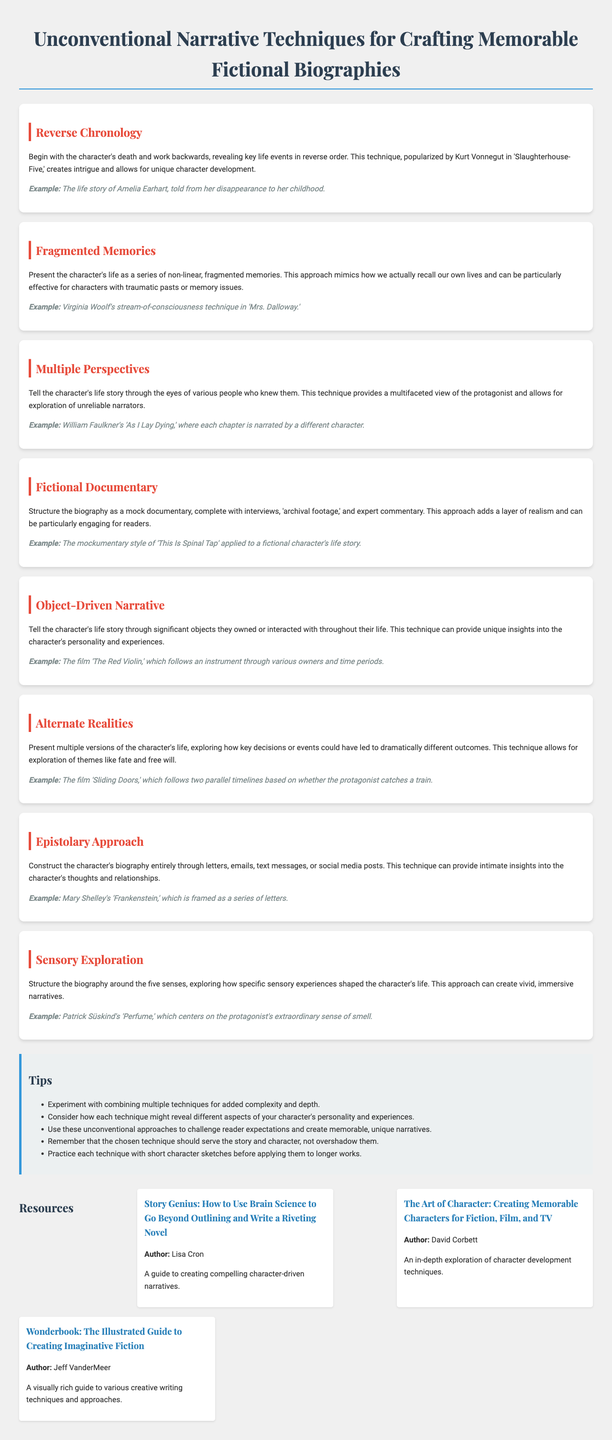What is the title of the brochure? The title of the brochure is provided at the top of the document.
Answer: Unconventional Narrative Techniques for Crafting Memorable Fictional Biographies How many narrative techniques are presented in the brochure? The brochure lists the narrative techniques in separate sections, which can be counted.
Answer: Eight Which technique uses non-linear memories? The technique's name is listed along with its description in the sections.
Answer: Fragmented Memories What example is given for Reverse Chronology? Each technique includes an example; the listed example specifies a particular character's life story.
Answer: The life story of Amelia Earhart, told from her disappearance to her childhood What is one tip provided in the brochure? The tips section contains several suggestions, and this can be retrieved directly from that list.
Answer: Experiment with combining multiple techniques for added complexity and depth Who is the author of "The Art of Character"? The resources section contains titles along with their authors, making this information readily available.
Answer: David Corbett Is "The Red Violin" an example of Object-Driven Narrative? The examples for narrative techniques are specified in the document, and each section provides an example.
Answer: Yes What is the description of the Epistolary Approach? The description is found in the appropriate section of the document and outlines the technique's characteristics.
Answer: Construct the character's biography entirely through letters, emails, text messages, or social media posts 